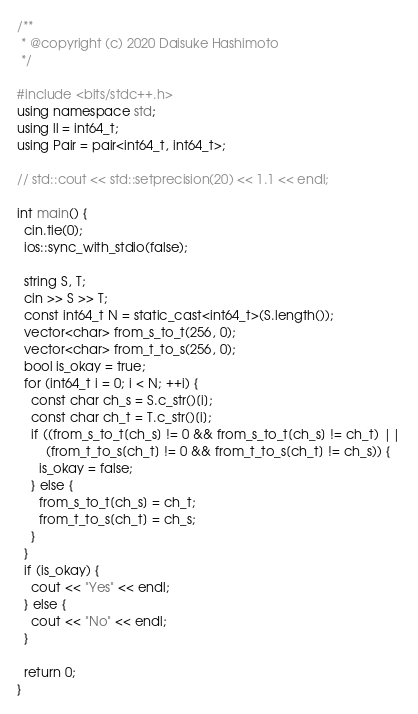<code> <loc_0><loc_0><loc_500><loc_500><_C++_>/**
 * @copyright (c) 2020 Daisuke Hashimoto
 */

#include <bits/stdc++.h>
using namespace std;
using ll = int64_t;
using Pair = pair<int64_t, int64_t>;

// std::cout << std::setprecision(20) << 1.1 << endl;

int main() {
  cin.tie(0);
  ios::sync_with_stdio(false);

  string S, T;
  cin >> S >> T;
  const int64_t N = static_cast<int64_t>(S.length());
  vector<char> from_s_to_t(256, 0);
  vector<char> from_t_to_s(256, 0);
  bool is_okay = true;
  for (int64_t i = 0; i < N; ++i) {
    const char ch_s = S.c_str()[i];
    const char ch_t = T.c_str()[i];
    if ((from_s_to_t[ch_s] != 0 && from_s_to_t[ch_s] != ch_t) ||
        (from_t_to_s[ch_t] != 0 && from_t_to_s[ch_t] != ch_s)) {
      is_okay = false;
    } else {
      from_s_to_t[ch_s] = ch_t;
      from_t_to_s[ch_t] = ch_s;
    }
  }
  if (is_okay) {
    cout << "Yes" << endl;
  } else {
    cout << "No" << endl;
  }

  return 0;
}
</code> 